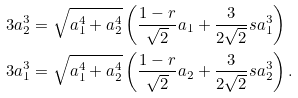Convert formula to latex. <formula><loc_0><loc_0><loc_500><loc_500>3 a _ { 2 } ^ { 3 } & = \sqrt { a _ { 1 } ^ { 4 } + a _ { 2 } ^ { 4 } } \left ( \frac { 1 - r } { \sqrt { 2 } } a _ { 1 } + \frac { 3 } { 2 \sqrt { 2 } } s a _ { 1 } ^ { 3 } \right ) \\ 3 a _ { 1 } ^ { 3 } & = \sqrt { a _ { 1 } ^ { 4 } + a _ { 2 } ^ { 4 } } \left ( \frac { 1 - r } { \sqrt { 2 } } a _ { 2 } + \frac { 3 } { 2 \sqrt { 2 } } s a _ { 2 } ^ { 3 } \right ) .</formula> 